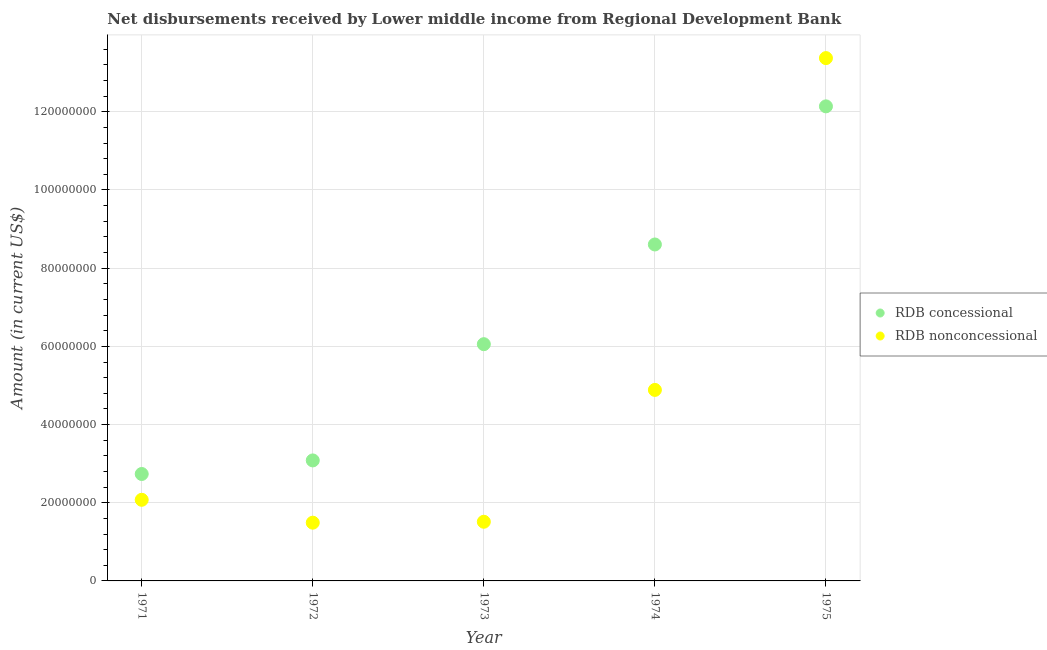How many different coloured dotlines are there?
Offer a terse response. 2. What is the net non concessional disbursements from rdb in 1973?
Make the answer very short. 1.51e+07. Across all years, what is the maximum net concessional disbursements from rdb?
Your response must be concise. 1.21e+08. Across all years, what is the minimum net non concessional disbursements from rdb?
Offer a terse response. 1.49e+07. In which year was the net non concessional disbursements from rdb maximum?
Provide a short and direct response. 1975. What is the total net concessional disbursements from rdb in the graph?
Offer a very short reply. 3.26e+08. What is the difference between the net non concessional disbursements from rdb in 1971 and that in 1974?
Your answer should be very brief. -2.81e+07. What is the difference between the net concessional disbursements from rdb in 1975 and the net non concessional disbursements from rdb in 1972?
Ensure brevity in your answer.  1.06e+08. What is the average net concessional disbursements from rdb per year?
Provide a succinct answer. 6.52e+07. In the year 1973, what is the difference between the net non concessional disbursements from rdb and net concessional disbursements from rdb?
Ensure brevity in your answer.  -4.54e+07. What is the ratio of the net non concessional disbursements from rdb in 1973 to that in 1974?
Offer a terse response. 0.31. Is the difference between the net non concessional disbursements from rdb in 1974 and 1975 greater than the difference between the net concessional disbursements from rdb in 1974 and 1975?
Your response must be concise. No. What is the difference between the highest and the second highest net concessional disbursements from rdb?
Your answer should be compact. 3.53e+07. What is the difference between the highest and the lowest net concessional disbursements from rdb?
Your answer should be compact. 9.40e+07. Is the sum of the net non concessional disbursements from rdb in 1971 and 1973 greater than the maximum net concessional disbursements from rdb across all years?
Offer a very short reply. No. Does the net non concessional disbursements from rdb monotonically increase over the years?
Make the answer very short. No. How many years are there in the graph?
Your answer should be compact. 5. What is the difference between two consecutive major ticks on the Y-axis?
Give a very brief answer. 2.00e+07. Does the graph contain grids?
Your response must be concise. Yes. Where does the legend appear in the graph?
Provide a short and direct response. Center right. What is the title of the graph?
Your answer should be very brief. Net disbursements received by Lower middle income from Regional Development Bank. Does "Register a property" appear as one of the legend labels in the graph?
Your response must be concise. No. What is the Amount (in current US$) of RDB concessional in 1971?
Your response must be concise. 2.74e+07. What is the Amount (in current US$) in RDB nonconcessional in 1971?
Provide a succinct answer. 2.08e+07. What is the Amount (in current US$) of RDB concessional in 1972?
Your response must be concise. 3.08e+07. What is the Amount (in current US$) in RDB nonconcessional in 1972?
Your answer should be compact. 1.49e+07. What is the Amount (in current US$) in RDB concessional in 1973?
Provide a short and direct response. 6.06e+07. What is the Amount (in current US$) in RDB nonconcessional in 1973?
Your response must be concise. 1.51e+07. What is the Amount (in current US$) in RDB concessional in 1974?
Keep it short and to the point. 8.61e+07. What is the Amount (in current US$) in RDB nonconcessional in 1974?
Make the answer very short. 4.89e+07. What is the Amount (in current US$) of RDB concessional in 1975?
Make the answer very short. 1.21e+08. What is the Amount (in current US$) of RDB nonconcessional in 1975?
Make the answer very short. 1.34e+08. Across all years, what is the maximum Amount (in current US$) in RDB concessional?
Your answer should be very brief. 1.21e+08. Across all years, what is the maximum Amount (in current US$) of RDB nonconcessional?
Your response must be concise. 1.34e+08. Across all years, what is the minimum Amount (in current US$) of RDB concessional?
Offer a terse response. 2.74e+07. Across all years, what is the minimum Amount (in current US$) of RDB nonconcessional?
Make the answer very short. 1.49e+07. What is the total Amount (in current US$) of RDB concessional in the graph?
Offer a terse response. 3.26e+08. What is the total Amount (in current US$) of RDB nonconcessional in the graph?
Offer a very short reply. 2.33e+08. What is the difference between the Amount (in current US$) in RDB concessional in 1971 and that in 1972?
Offer a terse response. -3.47e+06. What is the difference between the Amount (in current US$) of RDB nonconcessional in 1971 and that in 1972?
Ensure brevity in your answer.  5.85e+06. What is the difference between the Amount (in current US$) in RDB concessional in 1971 and that in 1973?
Your answer should be very brief. -3.32e+07. What is the difference between the Amount (in current US$) of RDB nonconcessional in 1971 and that in 1973?
Provide a short and direct response. 5.62e+06. What is the difference between the Amount (in current US$) in RDB concessional in 1971 and that in 1974?
Keep it short and to the point. -5.87e+07. What is the difference between the Amount (in current US$) in RDB nonconcessional in 1971 and that in 1974?
Offer a terse response. -2.81e+07. What is the difference between the Amount (in current US$) in RDB concessional in 1971 and that in 1975?
Ensure brevity in your answer.  -9.40e+07. What is the difference between the Amount (in current US$) in RDB nonconcessional in 1971 and that in 1975?
Your answer should be compact. -1.13e+08. What is the difference between the Amount (in current US$) in RDB concessional in 1972 and that in 1973?
Provide a short and direct response. -2.97e+07. What is the difference between the Amount (in current US$) of RDB nonconcessional in 1972 and that in 1973?
Keep it short and to the point. -2.36e+05. What is the difference between the Amount (in current US$) of RDB concessional in 1972 and that in 1974?
Your answer should be very brief. -5.52e+07. What is the difference between the Amount (in current US$) of RDB nonconcessional in 1972 and that in 1974?
Ensure brevity in your answer.  -3.40e+07. What is the difference between the Amount (in current US$) of RDB concessional in 1972 and that in 1975?
Offer a very short reply. -9.06e+07. What is the difference between the Amount (in current US$) of RDB nonconcessional in 1972 and that in 1975?
Your answer should be very brief. -1.19e+08. What is the difference between the Amount (in current US$) of RDB concessional in 1973 and that in 1974?
Keep it short and to the point. -2.55e+07. What is the difference between the Amount (in current US$) of RDB nonconcessional in 1973 and that in 1974?
Your response must be concise. -3.37e+07. What is the difference between the Amount (in current US$) of RDB concessional in 1973 and that in 1975?
Keep it short and to the point. -6.08e+07. What is the difference between the Amount (in current US$) in RDB nonconcessional in 1973 and that in 1975?
Provide a short and direct response. -1.19e+08. What is the difference between the Amount (in current US$) in RDB concessional in 1974 and that in 1975?
Provide a short and direct response. -3.53e+07. What is the difference between the Amount (in current US$) of RDB nonconcessional in 1974 and that in 1975?
Ensure brevity in your answer.  -8.49e+07. What is the difference between the Amount (in current US$) of RDB concessional in 1971 and the Amount (in current US$) of RDB nonconcessional in 1972?
Offer a very short reply. 1.25e+07. What is the difference between the Amount (in current US$) in RDB concessional in 1971 and the Amount (in current US$) in RDB nonconcessional in 1973?
Provide a short and direct response. 1.22e+07. What is the difference between the Amount (in current US$) of RDB concessional in 1971 and the Amount (in current US$) of RDB nonconcessional in 1974?
Give a very brief answer. -2.15e+07. What is the difference between the Amount (in current US$) in RDB concessional in 1971 and the Amount (in current US$) in RDB nonconcessional in 1975?
Keep it short and to the point. -1.06e+08. What is the difference between the Amount (in current US$) in RDB concessional in 1972 and the Amount (in current US$) in RDB nonconcessional in 1973?
Offer a very short reply. 1.57e+07. What is the difference between the Amount (in current US$) in RDB concessional in 1972 and the Amount (in current US$) in RDB nonconcessional in 1974?
Give a very brief answer. -1.80e+07. What is the difference between the Amount (in current US$) in RDB concessional in 1972 and the Amount (in current US$) in RDB nonconcessional in 1975?
Provide a short and direct response. -1.03e+08. What is the difference between the Amount (in current US$) in RDB concessional in 1973 and the Amount (in current US$) in RDB nonconcessional in 1974?
Make the answer very short. 1.17e+07. What is the difference between the Amount (in current US$) of RDB concessional in 1973 and the Amount (in current US$) of RDB nonconcessional in 1975?
Your answer should be compact. -7.32e+07. What is the difference between the Amount (in current US$) in RDB concessional in 1974 and the Amount (in current US$) in RDB nonconcessional in 1975?
Keep it short and to the point. -4.77e+07. What is the average Amount (in current US$) of RDB concessional per year?
Provide a succinct answer. 6.52e+07. What is the average Amount (in current US$) in RDB nonconcessional per year?
Keep it short and to the point. 4.67e+07. In the year 1971, what is the difference between the Amount (in current US$) in RDB concessional and Amount (in current US$) in RDB nonconcessional?
Keep it short and to the point. 6.60e+06. In the year 1972, what is the difference between the Amount (in current US$) in RDB concessional and Amount (in current US$) in RDB nonconcessional?
Your answer should be very brief. 1.59e+07. In the year 1973, what is the difference between the Amount (in current US$) of RDB concessional and Amount (in current US$) of RDB nonconcessional?
Ensure brevity in your answer.  4.54e+07. In the year 1974, what is the difference between the Amount (in current US$) in RDB concessional and Amount (in current US$) in RDB nonconcessional?
Make the answer very short. 3.72e+07. In the year 1975, what is the difference between the Amount (in current US$) of RDB concessional and Amount (in current US$) of RDB nonconcessional?
Provide a short and direct response. -1.23e+07. What is the ratio of the Amount (in current US$) in RDB concessional in 1971 to that in 1972?
Your response must be concise. 0.89. What is the ratio of the Amount (in current US$) in RDB nonconcessional in 1971 to that in 1972?
Provide a succinct answer. 1.39. What is the ratio of the Amount (in current US$) of RDB concessional in 1971 to that in 1973?
Offer a terse response. 0.45. What is the ratio of the Amount (in current US$) of RDB nonconcessional in 1971 to that in 1973?
Offer a very short reply. 1.37. What is the ratio of the Amount (in current US$) of RDB concessional in 1971 to that in 1974?
Provide a short and direct response. 0.32. What is the ratio of the Amount (in current US$) in RDB nonconcessional in 1971 to that in 1974?
Your answer should be compact. 0.42. What is the ratio of the Amount (in current US$) in RDB concessional in 1971 to that in 1975?
Your response must be concise. 0.23. What is the ratio of the Amount (in current US$) of RDB nonconcessional in 1971 to that in 1975?
Offer a terse response. 0.16. What is the ratio of the Amount (in current US$) in RDB concessional in 1972 to that in 1973?
Keep it short and to the point. 0.51. What is the ratio of the Amount (in current US$) in RDB nonconcessional in 1972 to that in 1973?
Your answer should be very brief. 0.98. What is the ratio of the Amount (in current US$) in RDB concessional in 1972 to that in 1974?
Provide a succinct answer. 0.36. What is the ratio of the Amount (in current US$) in RDB nonconcessional in 1972 to that in 1974?
Provide a succinct answer. 0.3. What is the ratio of the Amount (in current US$) in RDB concessional in 1972 to that in 1975?
Your response must be concise. 0.25. What is the ratio of the Amount (in current US$) of RDB nonconcessional in 1972 to that in 1975?
Your answer should be compact. 0.11. What is the ratio of the Amount (in current US$) of RDB concessional in 1973 to that in 1974?
Keep it short and to the point. 0.7. What is the ratio of the Amount (in current US$) in RDB nonconcessional in 1973 to that in 1974?
Your answer should be compact. 0.31. What is the ratio of the Amount (in current US$) in RDB concessional in 1973 to that in 1975?
Provide a succinct answer. 0.5. What is the ratio of the Amount (in current US$) in RDB nonconcessional in 1973 to that in 1975?
Your answer should be very brief. 0.11. What is the ratio of the Amount (in current US$) of RDB concessional in 1974 to that in 1975?
Make the answer very short. 0.71. What is the ratio of the Amount (in current US$) of RDB nonconcessional in 1974 to that in 1975?
Keep it short and to the point. 0.37. What is the difference between the highest and the second highest Amount (in current US$) of RDB concessional?
Your response must be concise. 3.53e+07. What is the difference between the highest and the second highest Amount (in current US$) in RDB nonconcessional?
Offer a terse response. 8.49e+07. What is the difference between the highest and the lowest Amount (in current US$) of RDB concessional?
Your answer should be very brief. 9.40e+07. What is the difference between the highest and the lowest Amount (in current US$) of RDB nonconcessional?
Your answer should be very brief. 1.19e+08. 